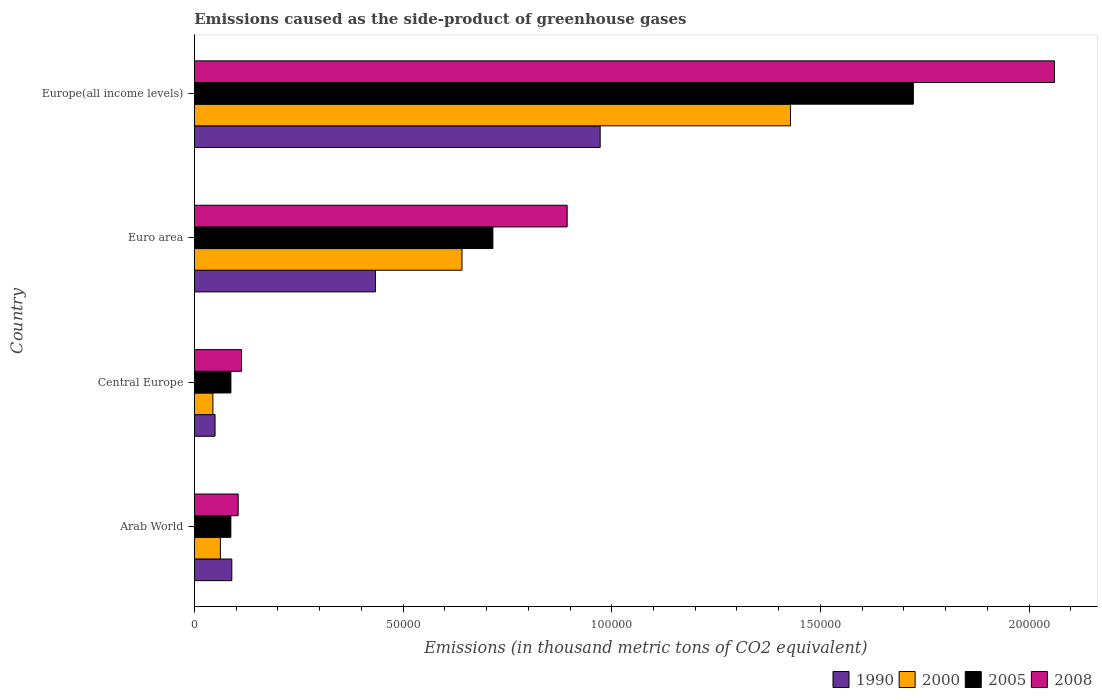How many groups of bars are there?
Offer a terse response. 4. Are the number of bars per tick equal to the number of legend labels?
Your answer should be very brief. Yes. How many bars are there on the 1st tick from the bottom?
Your answer should be compact. 4. What is the label of the 2nd group of bars from the top?
Your answer should be very brief. Euro area. In how many cases, is the number of bars for a given country not equal to the number of legend labels?
Keep it short and to the point. 0. What is the emissions caused as the side-product of greenhouse gases in 2005 in Central Europe?
Provide a succinct answer. 8777.6. Across all countries, what is the maximum emissions caused as the side-product of greenhouse gases in 2008?
Give a very brief answer. 2.06e+05. Across all countries, what is the minimum emissions caused as the side-product of greenhouse gases in 2005?
Make the answer very short. 8766.4. In which country was the emissions caused as the side-product of greenhouse gases in 2005 maximum?
Offer a terse response. Europe(all income levels). In which country was the emissions caused as the side-product of greenhouse gases in 1990 minimum?
Offer a very short reply. Central Europe. What is the total emissions caused as the side-product of greenhouse gases in 2005 in the graph?
Keep it short and to the point. 2.61e+05. What is the difference between the emissions caused as the side-product of greenhouse gases in 2008 in Arab World and that in Europe(all income levels)?
Offer a very short reply. -1.96e+05. What is the difference between the emissions caused as the side-product of greenhouse gases in 2000 in Arab World and the emissions caused as the side-product of greenhouse gases in 2008 in Europe(all income levels)?
Your answer should be very brief. -2.00e+05. What is the average emissions caused as the side-product of greenhouse gases in 2008 per country?
Make the answer very short. 7.93e+04. What is the difference between the emissions caused as the side-product of greenhouse gases in 1990 and emissions caused as the side-product of greenhouse gases in 2000 in Arab World?
Your response must be concise. 2742.8. What is the ratio of the emissions caused as the side-product of greenhouse gases in 2000 in Central Europe to that in Europe(all income levels)?
Offer a terse response. 0.03. Is the difference between the emissions caused as the side-product of greenhouse gases in 1990 in Arab World and Euro area greater than the difference between the emissions caused as the side-product of greenhouse gases in 2000 in Arab World and Euro area?
Ensure brevity in your answer.  Yes. What is the difference between the highest and the second highest emissions caused as the side-product of greenhouse gases in 2005?
Provide a short and direct response. 1.01e+05. What is the difference between the highest and the lowest emissions caused as the side-product of greenhouse gases in 2005?
Provide a short and direct response. 1.63e+05. Is the sum of the emissions caused as the side-product of greenhouse gases in 2005 in Central Europe and Euro area greater than the maximum emissions caused as the side-product of greenhouse gases in 2008 across all countries?
Offer a very short reply. No. Is it the case that in every country, the sum of the emissions caused as the side-product of greenhouse gases in 2000 and emissions caused as the side-product of greenhouse gases in 1990 is greater than the sum of emissions caused as the side-product of greenhouse gases in 2005 and emissions caused as the side-product of greenhouse gases in 2008?
Offer a very short reply. No. How many bars are there?
Keep it short and to the point. 16. Are the values on the major ticks of X-axis written in scientific E-notation?
Ensure brevity in your answer.  No. Does the graph contain any zero values?
Offer a very short reply. No. Does the graph contain grids?
Ensure brevity in your answer.  No. How many legend labels are there?
Ensure brevity in your answer.  4. How are the legend labels stacked?
Offer a terse response. Horizontal. What is the title of the graph?
Your response must be concise. Emissions caused as the side-product of greenhouse gases. What is the label or title of the X-axis?
Your answer should be compact. Emissions (in thousand metric tons of CO2 equivalent). What is the label or title of the Y-axis?
Your answer should be very brief. Country. What is the Emissions (in thousand metric tons of CO2 equivalent) in 1990 in Arab World?
Offer a terse response. 8995.4. What is the Emissions (in thousand metric tons of CO2 equivalent) of 2000 in Arab World?
Your response must be concise. 6252.6. What is the Emissions (in thousand metric tons of CO2 equivalent) in 2005 in Arab World?
Your response must be concise. 8766.4. What is the Emissions (in thousand metric tons of CO2 equivalent) of 2008 in Arab World?
Give a very brief answer. 1.05e+04. What is the Emissions (in thousand metric tons of CO2 equivalent) of 1990 in Central Europe?
Your response must be concise. 4981.9. What is the Emissions (in thousand metric tons of CO2 equivalent) of 2000 in Central Europe?
Your answer should be very brief. 4466.9. What is the Emissions (in thousand metric tons of CO2 equivalent) in 2005 in Central Europe?
Offer a very short reply. 8777.6. What is the Emissions (in thousand metric tons of CO2 equivalent) in 2008 in Central Europe?
Make the answer very short. 1.13e+04. What is the Emissions (in thousand metric tons of CO2 equivalent) in 1990 in Euro area?
Ensure brevity in your answer.  4.34e+04. What is the Emissions (in thousand metric tons of CO2 equivalent) in 2000 in Euro area?
Provide a short and direct response. 6.41e+04. What is the Emissions (in thousand metric tons of CO2 equivalent) of 2005 in Euro area?
Ensure brevity in your answer.  7.15e+04. What is the Emissions (in thousand metric tons of CO2 equivalent) of 2008 in Euro area?
Your answer should be compact. 8.93e+04. What is the Emissions (in thousand metric tons of CO2 equivalent) in 1990 in Europe(all income levels)?
Your answer should be compact. 9.72e+04. What is the Emissions (in thousand metric tons of CO2 equivalent) in 2000 in Europe(all income levels)?
Offer a terse response. 1.43e+05. What is the Emissions (in thousand metric tons of CO2 equivalent) of 2005 in Europe(all income levels)?
Your response must be concise. 1.72e+05. What is the Emissions (in thousand metric tons of CO2 equivalent) in 2008 in Europe(all income levels)?
Your answer should be very brief. 2.06e+05. Across all countries, what is the maximum Emissions (in thousand metric tons of CO2 equivalent) in 1990?
Keep it short and to the point. 9.72e+04. Across all countries, what is the maximum Emissions (in thousand metric tons of CO2 equivalent) in 2000?
Make the answer very short. 1.43e+05. Across all countries, what is the maximum Emissions (in thousand metric tons of CO2 equivalent) of 2005?
Your response must be concise. 1.72e+05. Across all countries, what is the maximum Emissions (in thousand metric tons of CO2 equivalent) in 2008?
Provide a short and direct response. 2.06e+05. Across all countries, what is the minimum Emissions (in thousand metric tons of CO2 equivalent) of 1990?
Keep it short and to the point. 4981.9. Across all countries, what is the minimum Emissions (in thousand metric tons of CO2 equivalent) in 2000?
Keep it short and to the point. 4466.9. Across all countries, what is the minimum Emissions (in thousand metric tons of CO2 equivalent) of 2005?
Keep it short and to the point. 8766.4. Across all countries, what is the minimum Emissions (in thousand metric tons of CO2 equivalent) of 2008?
Make the answer very short. 1.05e+04. What is the total Emissions (in thousand metric tons of CO2 equivalent) of 1990 in the graph?
Your response must be concise. 1.55e+05. What is the total Emissions (in thousand metric tons of CO2 equivalent) in 2000 in the graph?
Provide a short and direct response. 2.18e+05. What is the total Emissions (in thousand metric tons of CO2 equivalent) of 2005 in the graph?
Ensure brevity in your answer.  2.61e+05. What is the total Emissions (in thousand metric tons of CO2 equivalent) in 2008 in the graph?
Keep it short and to the point. 3.17e+05. What is the difference between the Emissions (in thousand metric tons of CO2 equivalent) in 1990 in Arab World and that in Central Europe?
Provide a short and direct response. 4013.5. What is the difference between the Emissions (in thousand metric tons of CO2 equivalent) in 2000 in Arab World and that in Central Europe?
Offer a very short reply. 1785.7. What is the difference between the Emissions (in thousand metric tons of CO2 equivalent) of 2008 in Arab World and that in Central Europe?
Offer a very short reply. -804.2. What is the difference between the Emissions (in thousand metric tons of CO2 equivalent) in 1990 in Arab World and that in Euro area?
Your answer should be very brief. -3.44e+04. What is the difference between the Emissions (in thousand metric tons of CO2 equivalent) of 2000 in Arab World and that in Euro area?
Your answer should be compact. -5.79e+04. What is the difference between the Emissions (in thousand metric tons of CO2 equivalent) of 2005 in Arab World and that in Euro area?
Keep it short and to the point. -6.28e+04. What is the difference between the Emissions (in thousand metric tons of CO2 equivalent) of 2008 in Arab World and that in Euro area?
Ensure brevity in your answer.  -7.88e+04. What is the difference between the Emissions (in thousand metric tons of CO2 equivalent) in 1990 in Arab World and that in Europe(all income levels)?
Ensure brevity in your answer.  -8.82e+04. What is the difference between the Emissions (in thousand metric tons of CO2 equivalent) of 2000 in Arab World and that in Europe(all income levels)?
Your answer should be compact. -1.37e+05. What is the difference between the Emissions (in thousand metric tons of CO2 equivalent) of 2005 in Arab World and that in Europe(all income levels)?
Provide a succinct answer. -1.63e+05. What is the difference between the Emissions (in thousand metric tons of CO2 equivalent) in 2008 in Arab World and that in Europe(all income levels)?
Your answer should be very brief. -1.96e+05. What is the difference between the Emissions (in thousand metric tons of CO2 equivalent) in 1990 in Central Europe and that in Euro area?
Ensure brevity in your answer.  -3.84e+04. What is the difference between the Emissions (in thousand metric tons of CO2 equivalent) in 2000 in Central Europe and that in Euro area?
Provide a short and direct response. -5.97e+04. What is the difference between the Emissions (in thousand metric tons of CO2 equivalent) in 2005 in Central Europe and that in Euro area?
Provide a succinct answer. -6.28e+04. What is the difference between the Emissions (in thousand metric tons of CO2 equivalent) of 2008 in Central Europe and that in Euro area?
Offer a terse response. -7.80e+04. What is the difference between the Emissions (in thousand metric tons of CO2 equivalent) of 1990 in Central Europe and that in Europe(all income levels)?
Give a very brief answer. -9.22e+04. What is the difference between the Emissions (in thousand metric tons of CO2 equivalent) of 2000 in Central Europe and that in Europe(all income levels)?
Offer a very short reply. -1.38e+05. What is the difference between the Emissions (in thousand metric tons of CO2 equivalent) of 2005 in Central Europe and that in Europe(all income levels)?
Offer a very short reply. -1.63e+05. What is the difference between the Emissions (in thousand metric tons of CO2 equivalent) in 2008 in Central Europe and that in Europe(all income levels)?
Provide a succinct answer. -1.95e+05. What is the difference between the Emissions (in thousand metric tons of CO2 equivalent) of 1990 in Euro area and that in Europe(all income levels)?
Your answer should be very brief. -5.38e+04. What is the difference between the Emissions (in thousand metric tons of CO2 equivalent) in 2000 in Euro area and that in Europe(all income levels)?
Provide a short and direct response. -7.87e+04. What is the difference between the Emissions (in thousand metric tons of CO2 equivalent) of 2005 in Euro area and that in Europe(all income levels)?
Ensure brevity in your answer.  -1.01e+05. What is the difference between the Emissions (in thousand metric tons of CO2 equivalent) in 2008 in Euro area and that in Europe(all income levels)?
Provide a succinct answer. -1.17e+05. What is the difference between the Emissions (in thousand metric tons of CO2 equivalent) of 1990 in Arab World and the Emissions (in thousand metric tons of CO2 equivalent) of 2000 in Central Europe?
Offer a terse response. 4528.5. What is the difference between the Emissions (in thousand metric tons of CO2 equivalent) of 1990 in Arab World and the Emissions (in thousand metric tons of CO2 equivalent) of 2005 in Central Europe?
Give a very brief answer. 217.8. What is the difference between the Emissions (in thousand metric tons of CO2 equivalent) in 1990 in Arab World and the Emissions (in thousand metric tons of CO2 equivalent) in 2008 in Central Europe?
Provide a succinct answer. -2328. What is the difference between the Emissions (in thousand metric tons of CO2 equivalent) of 2000 in Arab World and the Emissions (in thousand metric tons of CO2 equivalent) of 2005 in Central Europe?
Offer a very short reply. -2525. What is the difference between the Emissions (in thousand metric tons of CO2 equivalent) in 2000 in Arab World and the Emissions (in thousand metric tons of CO2 equivalent) in 2008 in Central Europe?
Provide a short and direct response. -5070.8. What is the difference between the Emissions (in thousand metric tons of CO2 equivalent) of 2005 in Arab World and the Emissions (in thousand metric tons of CO2 equivalent) of 2008 in Central Europe?
Offer a terse response. -2557. What is the difference between the Emissions (in thousand metric tons of CO2 equivalent) of 1990 in Arab World and the Emissions (in thousand metric tons of CO2 equivalent) of 2000 in Euro area?
Your answer should be compact. -5.51e+04. What is the difference between the Emissions (in thousand metric tons of CO2 equivalent) of 1990 in Arab World and the Emissions (in thousand metric tons of CO2 equivalent) of 2005 in Euro area?
Your response must be concise. -6.25e+04. What is the difference between the Emissions (in thousand metric tons of CO2 equivalent) of 1990 in Arab World and the Emissions (in thousand metric tons of CO2 equivalent) of 2008 in Euro area?
Provide a succinct answer. -8.03e+04. What is the difference between the Emissions (in thousand metric tons of CO2 equivalent) of 2000 in Arab World and the Emissions (in thousand metric tons of CO2 equivalent) of 2005 in Euro area?
Your answer should be compact. -6.53e+04. What is the difference between the Emissions (in thousand metric tons of CO2 equivalent) in 2000 in Arab World and the Emissions (in thousand metric tons of CO2 equivalent) in 2008 in Euro area?
Offer a very short reply. -8.31e+04. What is the difference between the Emissions (in thousand metric tons of CO2 equivalent) in 2005 in Arab World and the Emissions (in thousand metric tons of CO2 equivalent) in 2008 in Euro area?
Offer a very short reply. -8.06e+04. What is the difference between the Emissions (in thousand metric tons of CO2 equivalent) in 1990 in Arab World and the Emissions (in thousand metric tons of CO2 equivalent) in 2000 in Europe(all income levels)?
Your answer should be compact. -1.34e+05. What is the difference between the Emissions (in thousand metric tons of CO2 equivalent) in 1990 in Arab World and the Emissions (in thousand metric tons of CO2 equivalent) in 2005 in Europe(all income levels)?
Offer a very short reply. -1.63e+05. What is the difference between the Emissions (in thousand metric tons of CO2 equivalent) in 1990 in Arab World and the Emissions (in thousand metric tons of CO2 equivalent) in 2008 in Europe(all income levels)?
Your answer should be compact. -1.97e+05. What is the difference between the Emissions (in thousand metric tons of CO2 equivalent) in 2000 in Arab World and the Emissions (in thousand metric tons of CO2 equivalent) in 2005 in Europe(all income levels)?
Ensure brevity in your answer.  -1.66e+05. What is the difference between the Emissions (in thousand metric tons of CO2 equivalent) of 2000 in Arab World and the Emissions (in thousand metric tons of CO2 equivalent) of 2008 in Europe(all income levels)?
Your response must be concise. -2.00e+05. What is the difference between the Emissions (in thousand metric tons of CO2 equivalent) in 2005 in Arab World and the Emissions (in thousand metric tons of CO2 equivalent) in 2008 in Europe(all income levels)?
Make the answer very short. -1.97e+05. What is the difference between the Emissions (in thousand metric tons of CO2 equivalent) of 1990 in Central Europe and the Emissions (in thousand metric tons of CO2 equivalent) of 2000 in Euro area?
Your response must be concise. -5.91e+04. What is the difference between the Emissions (in thousand metric tons of CO2 equivalent) in 1990 in Central Europe and the Emissions (in thousand metric tons of CO2 equivalent) in 2005 in Euro area?
Your answer should be very brief. -6.65e+04. What is the difference between the Emissions (in thousand metric tons of CO2 equivalent) in 1990 in Central Europe and the Emissions (in thousand metric tons of CO2 equivalent) in 2008 in Euro area?
Offer a very short reply. -8.43e+04. What is the difference between the Emissions (in thousand metric tons of CO2 equivalent) in 2000 in Central Europe and the Emissions (in thousand metric tons of CO2 equivalent) in 2005 in Euro area?
Keep it short and to the point. -6.71e+04. What is the difference between the Emissions (in thousand metric tons of CO2 equivalent) of 2000 in Central Europe and the Emissions (in thousand metric tons of CO2 equivalent) of 2008 in Euro area?
Your response must be concise. -8.49e+04. What is the difference between the Emissions (in thousand metric tons of CO2 equivalent) in 2005 in Central Europe and the Emissions (in thousand metric tons of CO2 equivalent) in 2008 in Euro area?
Your response must be concise. -8.05e+04. What is the difference between the Emissions (in thousand metric tons of CO2 equivalent) in 1990 in Central Europe and the Emissions (in thousand metric tons of CO2 equivalent) in 2000 in Europe(all income levels)?
Provide a succinct answer. -1.38e+05. What is the difference between the Emissions (in thousand metric tons of CO2 equivalent) in 1990 in Central Europe and the Emissions (in thousand metric tons of CO2 equivalent) in 2005 in Europe(all income levels)?
Provide a short and direct response. -1.67e+05. What is the difference between the Emissions (in thousand metric tons of CO2 equivalent) of 1990 in Central Europe and the Emissions (in thousand metric tons of CO2 equivalent) of 2008 in Europe(all income levels)?
Your answer should be very brief. -2.01e+05. What is the difference between the Emissions (in thousand metric tons of CO2 equivalent) in 2000 in Central Europe and the Emissions (in thousand metric tons of CO2 equivalent) in 2005 in Europe(all income levels)?
Your answer should be compact. -1.68e+05. What is the difference between the Emissions (in thousand metric tons of CO2 equivalent) of 2000 in Central Europe and the Emissions (in thousand metric tons of CO2 equivalent) of 2008 in Europe(all income levels)?
Your answer should be compact. -2.02e+05. What is the difference between the Emissions (in thousand metric tons of CO2 equivalent) of 2005 in Central Europe and the Emissions (in thousand metric tons of CO2 equivalent) of 2008 in Europe(all income levels)?
Your response must be concise. -1.97e+05. What is the difference between the Emissions (in thousand metric tons of CO2 equivalent) in 1990 in Euro area and the Emissions (in thousand metric tons of CO2 equivalent) in 2000 in Europe(all income levels)?
Make the answer very short. -9.94e+04. What is the difference between the Emissions (in thousand metric tons of CO2 equivalent) in 1990 in Euro area and the Emissions (in thousand metric tons of CO2 equivalent) in 2005 in Europe(all income levels)?
Give a very brief answer. -1.29e+05. What is the difference between the Emissions (in thousand metric tons of CO2 equivalent) of 1990 in Euro area and the Emissions (in thousand metric tons of CO2 equivalent) of 2008 in Europe(all income levels)?
Provide a short and direct response. -1.63e+05. What is the difference between the Emissions (in thousand metric tons of CO2 equivalent) of 2000 in Euro area and the Emissions (in thousand metric tons of CO2 equivalent) of 2005 in Europe(all income levels)?
Your answer should be compact. -1.08e+05. What is the difference between the Emissions (in thousand metric tons of CO2 equivalent) of 2000 in Euro area and the Emissions (in thousand metric tons of CO2 equivalent) of 2008 in Europe(all income levels)?
Your response must be concise. -1.42e+05. What is the difference between the Emissions (in thousand metric tons of CO2 equivalent) in 2005 in Euro area and the Emissions (in thousand metric tons of CO2 equivalent) in 2008 in Europe(all income levels)?
Keep it short and to the point. -1.35e+05. What is the average Emissions (in thousand metric tons of CO2 equivalent) of 1990 per country?
Make the answer very short. 3.87e+04. What is the average Emissions (in thousand metric tons of CO2 equivalent) in 2000 per country?
Give a very brief answer. 5.44e+04. What is the average Emissions (in thousand metric tons of CO2 equivalent) in 2005 per country?
Provide a short and direct response. 6.53e+04. What is the average Emissions (in thousand metric tons of CO2 equivalent) of 2008 per country?
Keep it short and to the point. 7.93e+04. What is the difference between the Emissions (in thousand metric tons of CO2 equivalent) of 1990 and Emissions (in thousand metric tons of CO2 equivalent) of 2000 in Arab World?
Your response must be concise. 2742.8. What is the difference between the Emissions (in thousand metric tons of CO2 equivalent) of 1990 and Emissions (in thousand metric tons of CO2 equivalent) of 2005 in Arab World?
Provide a short and direct response. 229. What is the difference between the Emissions (in thousand metric tons of CO2 equivalent) of 1990 and Emissions (in thousand metric tons of CO2 equivalent) of 2008 in Arab World?
Your response must be concise. -1523.8. What is the difference between the Emissions (in thousand metric tons of CO2 equivalent) of 2000 and Emissions (in thousand metric tons of CO2 equivalent) of 2005 in Arab World?
Offer a terse response. -2513.8. What is the difference between the Emissions (in thousand metric tons of CO2 equivalent) of 2000 and Emissions (in thousand metric tons of CO2 equivalent) of 2008 in Arab World?
Offer a very short reply. -4266.6. What is the difference between the Emissions (in thousand metric tons of CO2 equivalent) in 2005 and Emissions (in thousand metric tons of CO2 equivalent) in 2008 in Arab World?
Ensure brevity in your answer.  -1752.8. What is the difference between the Emissions (in thousand metric tons of CO2 equivalent) of 1990 and Emissions (in thousand metric tons of CO2 equivalent) of 2000 in Central Europe?
Make the answer very short. 515. What is the difference between the Emissions (in thousand metric tons of CO2 equivalent) in 1990 and Emissions (in thousand metric tons of CO2 equivalent) in 2005 in Central Europe?
Give a very brief answer. -3795.7. What is the difference between the Emissions (in thousand metric tons of CO2 equivalent) in 1990 and Emissions (in thousand metric tons of CO2 equivalent) in 2008 in Central Europe?
Your answer should be compact. -6341.5. What is the difference between the Emissions (in thousand metric tons of CO2 equivalent) in 2000 and Emissions (in thousand metric tons of CO2 equivalent) in 2005 in Central Europe?
Your answer should be compact. -4310.7. What is the difference between the Emissions (in thousand metric tons of CO2 equivalent) of 2000 and Emissions (in thousand metric tons of CO2 equivalent) of 2008 in Central Europe?
Your response must be concise. -6856.5. What is the difference between the Emissions (in thousand metric tons of CO2 equivalent) in 2005 and Emissions (in thousand metric tons of CO2 equivalent) in 2008 in Central Europe?
Provide a succinct answer. -2545.8. What is the difference between the Emissions (in thousand metric tons of CO2 equivalent) of 1990 and Emissions (in thousand metric tons of CO2 equivalent) of 2000 in Euro area?
Offer a terse response. -2.07e+04. What is the difference between the Emissions (in thousand metric tons of CO2 equivalent) of 1990 and Emissions (in thousand metric tons of CO2 equivalent) of 2005 in Euro area?
Your response must be concise. -2.81e+04. What is the difference between the Emissions (in thousand metric tons of CO2 equivalent) in 1990 and Emissions (in thousand metric tons of CO2 equivalent) in 2008 in Euro area?
Your response must be concise. -4.59e+04. What is the difference between the Emissions (in thousand metric tons of CO2 equivalent) in 2000 and Emissions (in thousand metric tons of CO2 equivalent) in 2005 in Euro area?
Offer a very short reply. -7401.3. What is the difference between the Emissions (in thousand metric tons of CO2 equivalent) of 2000 and Emissions (in thousand metric tons of CO2 equivalent) of 2008 in Euro area?
Ensure brevity in your answer.  -2.52e+04. What is the difference between the Emissions (in thousand metric tons of CO2 equivalent) of 2005 and Emissions (in thousand metric tons of CO2 equivalent) of 2008 in Euro area?
Offer a terse response. -1.78e+04. What is the difference between the Emissions (in thousand metric tons of CO2 equivalent) of 1990 and Emissions (in thousand metric tons of CO2 equivalent) of 2000 in Europe(all income levels)?
Your answer should be very brief. -4.56e+04. What is the difference between the Emissions (in thousand metric tons of CO2 equivalent) of 1990 and Emissions (in thousand metric tons of CO2 equivalent) of 2005 in Europe(all income levels)?
Your answer should be compact. -7.50e+04. What is the difference between the Emissions (in thousand metric tons of CO2 equivalent) in 1990 and Emissions (in thousand metric tons of CO2 equivalent) in 2008 in Europe(all income levels)?
Give a very brief answer. -1.09e+05. What is the difference between the Emissions (in thousand metric tons of CO2 equivalent) of 2000 and Emissions (in thousand metric tons of CO2 equivalent) of 2005 in Europe(all income levels)?
Provide a succinct answer. -2.94e+04. What is the difference between the Emissions (in thousand metric tons of CO2 equivalent) of 2000 and Emissions (in thousand metric tons of CO2 equivalent) of 2008 in Europe(all income levels)?
Give a very brief answer. -6.32e+04. What is the difference between the Emissions (in thousand metric tons of CO2 equivalent) in 2005 and Emissions (in thousand metric tons of CO2 equivalent) in 2008 in Europe(all income levels)?
Your response must be concise. -3.38e+04. What is the ratio of the Emissions (in thousand metric tons of CO2 equivalent) in 1990 in Arab World to that in Central Europe?
Offer a very short reply. 1.81. What is the ratio of the Emissions (in thousand metric tons of CO2 equivalent) of 2000 in Arab World to that in Central Europe?
Make the answer very short. 1.4. What is the ratio of the Emissions (in thousand metric tons of CO2 equivalent) in 2008 in Arab World to that in Central Europe?
Offer a very short reply. 0.93. What is the ratio of the Emissions (in thousand metric tons of CO2 equivalent) in 1990 in Arab World to that in Euro area?
Ensure brevity in your answer.  0.21. What is the ratio of the Emissions (in thousand metric tons of CO2 equivalent) in 2000 in Arab World to that in Euro area?
Provide a succinct answer. 0.1. What is the ratio of the Emissions (in thousand metric tons of CO2 equivalent) in 2005 in Arab World to that in Euro area?
Provide a succinct answer. 0.12. What is the ratio of the Emissions (in thousand metric tons of CO2 equivalent) in 2008 in Arab World to that in Euro area?
Provide a short and direct response. 0.12. What is the ratio of the Emissions (in thousand metric tons of CO2 equivalent) in 1990 in Arab World to that in Europe(all income levels)?
Offer a very short reply. 0.09. What is the ratio of the Emissions (in thousand metric tons of CO2 equivalent) in 2000 in Arab World to that in Europe(all income levels)?
Your answer should be compact. 0.04. What is the ratio of the Emissions (in thousand metric tons of CO2 equivalent) of 2005 in Arab World to that in Europe(all income levels)?
Provide a succinct answer. 0.05. What is the ratio of the Emissions (in thousand metric tons of CO2 equivalent) of 2008 in Arab World to that in Europe(all income levels)?
Your answer should be very brief. 0.05. What is the ratio of the Emissions (in thousand metric tons of CO2 equivalent) in 1990 in Central Europe to that in Euro area?
Your answer should be very brief. 0.11. What is the ratio of the Emissions (in thousand metric tons of CO2 equivalent) of 2000 in Central Europe to that in Euro area?
Ensure brevity in your answer.  0.07. What is the ratio of the Emissions (in thousand metric tons of CO2 equivalent) in 2005 in Central Europe to that in Euro area?
Your response must be concise. 0.12. What is the ratio of the Emissions (in thousand metric tons of CO2 equivalent) in 2008 in Central Europe to that in Euro area?
Give a very brief answer. 0.13. What is the ratio of the Emissions (in thousand metric tons of CO2 equivalent) in 1990 in Central Europe to that in Europe(all income levels)?
Provide a succinct answer. 0.05. What is the ratio of the Emissions (in thousand metric tons of CO2 equivalent) in 2000 in Central Europe to that in Europe(all income levels)?
Provide a short and direct response. 0.03. What is the ratio of the Emissions (in thousand metric tons of CO2 equivalent) of 2005 in Central Europe to that in Europe(all income levels)?
Keep it short and to the point. 0.05. What is the ratio of the Emissions (in thousand metric tons of CO2 equivalent) in 2008 in Central Europe to that in Europe(all income levels)?
Give a very brief answer. 0.06. What is the ratio of the Emissions (in thousand metric tons of CO2 equivalent) in 1990 in Euro area to that in Europe(all income levels)?
Your answer should be compact. 0.45. What is the ratio of the Emissions (in thousand metric tons of CO2 equivalent) of 2000 in Euro area to that in Europe(all income levels)?
Keep it short and to the point. 0.45. What is the ratio of the Emissions (in thousand metric tons of CO2 equivalent) of 2005 in Euro area to that in Europe(all income levels)?
Offer a very short reply. 0.42. What is the ratio of the Emissions (in thousand metric tons of CO2 equivalent) in 2008 in Euro area to that in Europe(all income levels)?
Your answer should be compact. 0.43. What is the difference between the highest and the second highest Emissions (in thousand metric tons of CO2 equivalent) in 1990?
Provide a succinct answer. 5.38e+04. What is the difference between the highest and the second highest Emissions (in thousand metric tons of CO2 equivalent) in 2000?
Make the answer very short. 7.87e+04. What is the difference between the highest and the second highest Emissions (in thousand metric tons of CO2 equivalent) in 2005?
Your answer should be very brief. 1.01e+05. What is the difference between the highest and the second highest Emissions (in thousand metric tons of CO2 equivalent) in 2008?
Make the answer very short. 1.17e+05. What is the difference between the highest and the lowest Emissions (in thousand metric tons of CO2 equivalent) in 1990?
Ensure brevity in your answer.  9.22e+04. What is the difference between the highest and the lowest Emissions (in thousand metric tons of CO2 equivalent) of 2000?
Provide a succinct answer. 1.38e+05. What is the difference between the highest and the lowest Emissions (in thousand metric tons of CO2 equivalent) of 2005?
Your answer should be very brief. 1.63e+05. What is the difference between the highest and the lowest Emissions (in thousand metric tons of CO2 equivalent) in 2008?
Keep it short and to the point. 1.96e+05. 